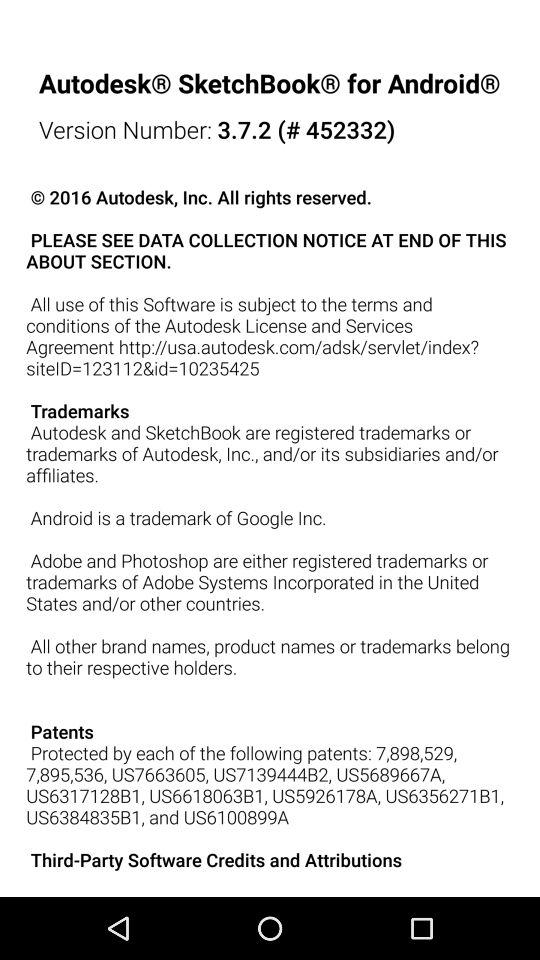What is the version of the application being used? The version of the application being used is 3.7.2 (# 452332). 